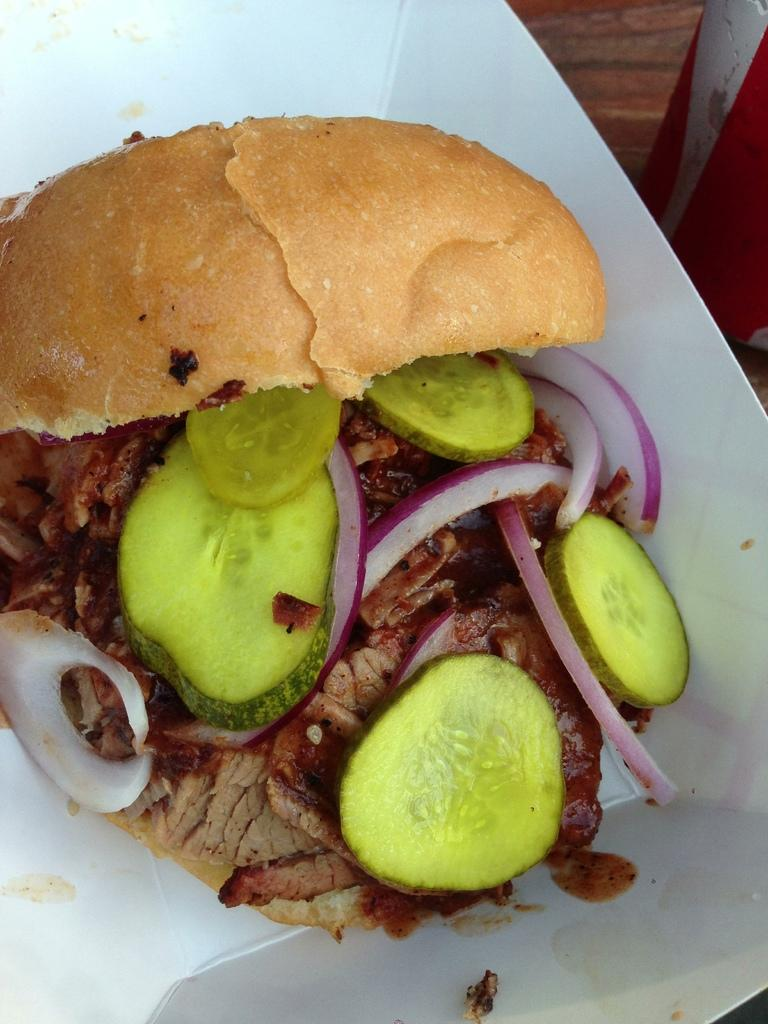What type of food is the main subject of the image? There is a burger in the image. What is the burger placed on? The burger is in a white plate. What type of vegetable can be seen in the image? There are cucumber slices in the image. What type of beverage is visible in the image? There is a coke tin in the image. What type of seed is being planted in the image? There is no seed or planting activity present in the image; it features a burger, cucumber slices, and a coke tin. 